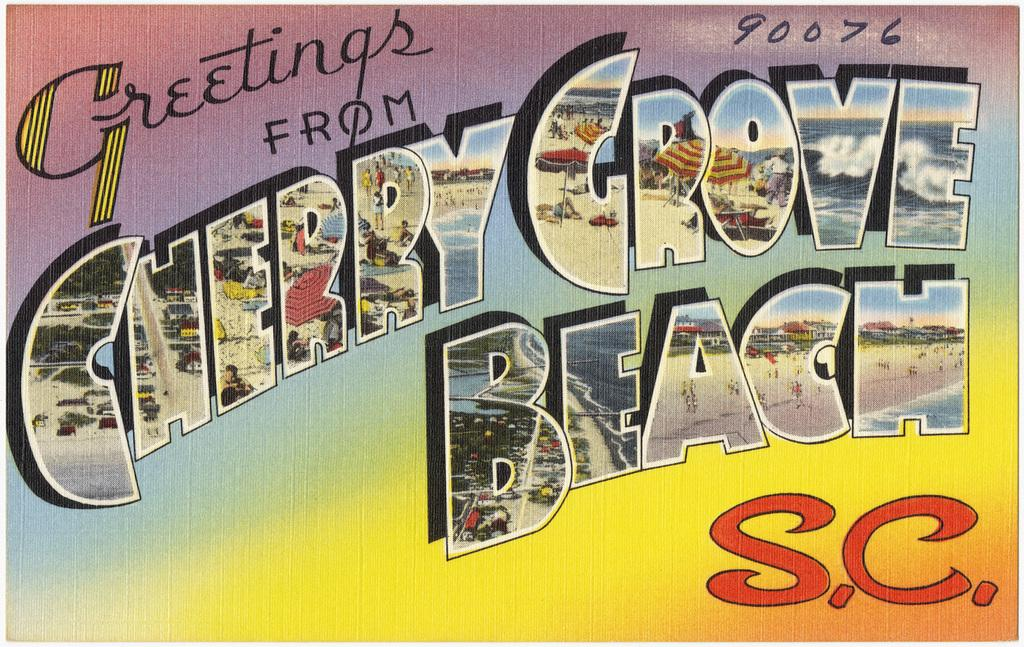<image>
Summarize the visual content of the image. A classic style postcard shows images of Cherry Grove Beach, S.C. 